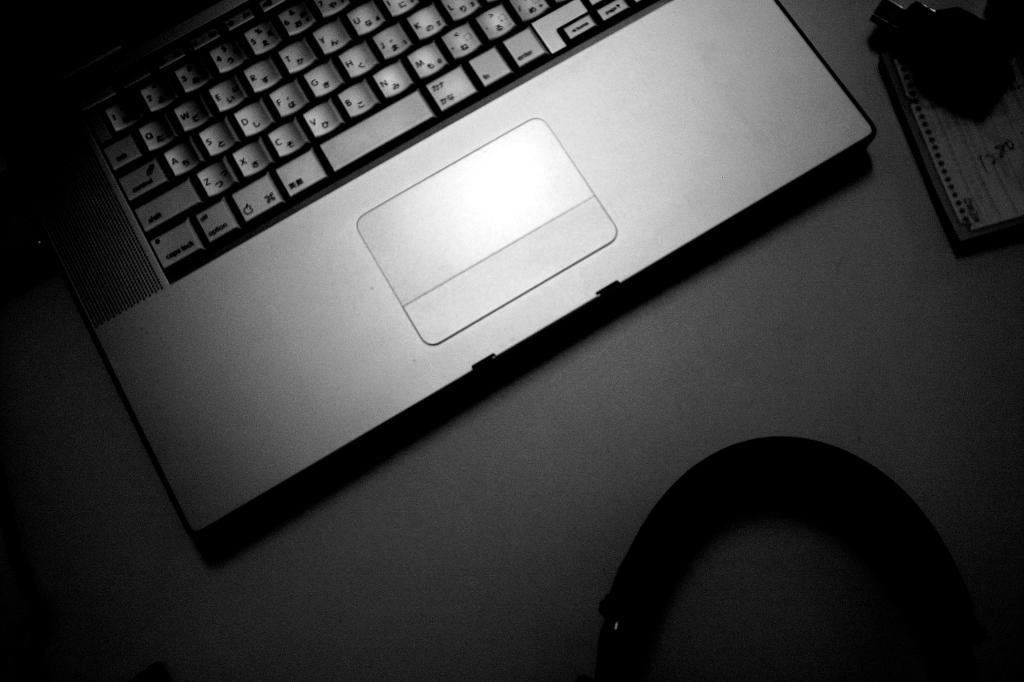What electronic device is visible in the image? There is a laptop in the image. Where is the laptop located? The laptop is placed on a table. What type of story is the goldfish telling in the image? There is no goldfish present in the image, and therefore no story can be told by a goldfish. 